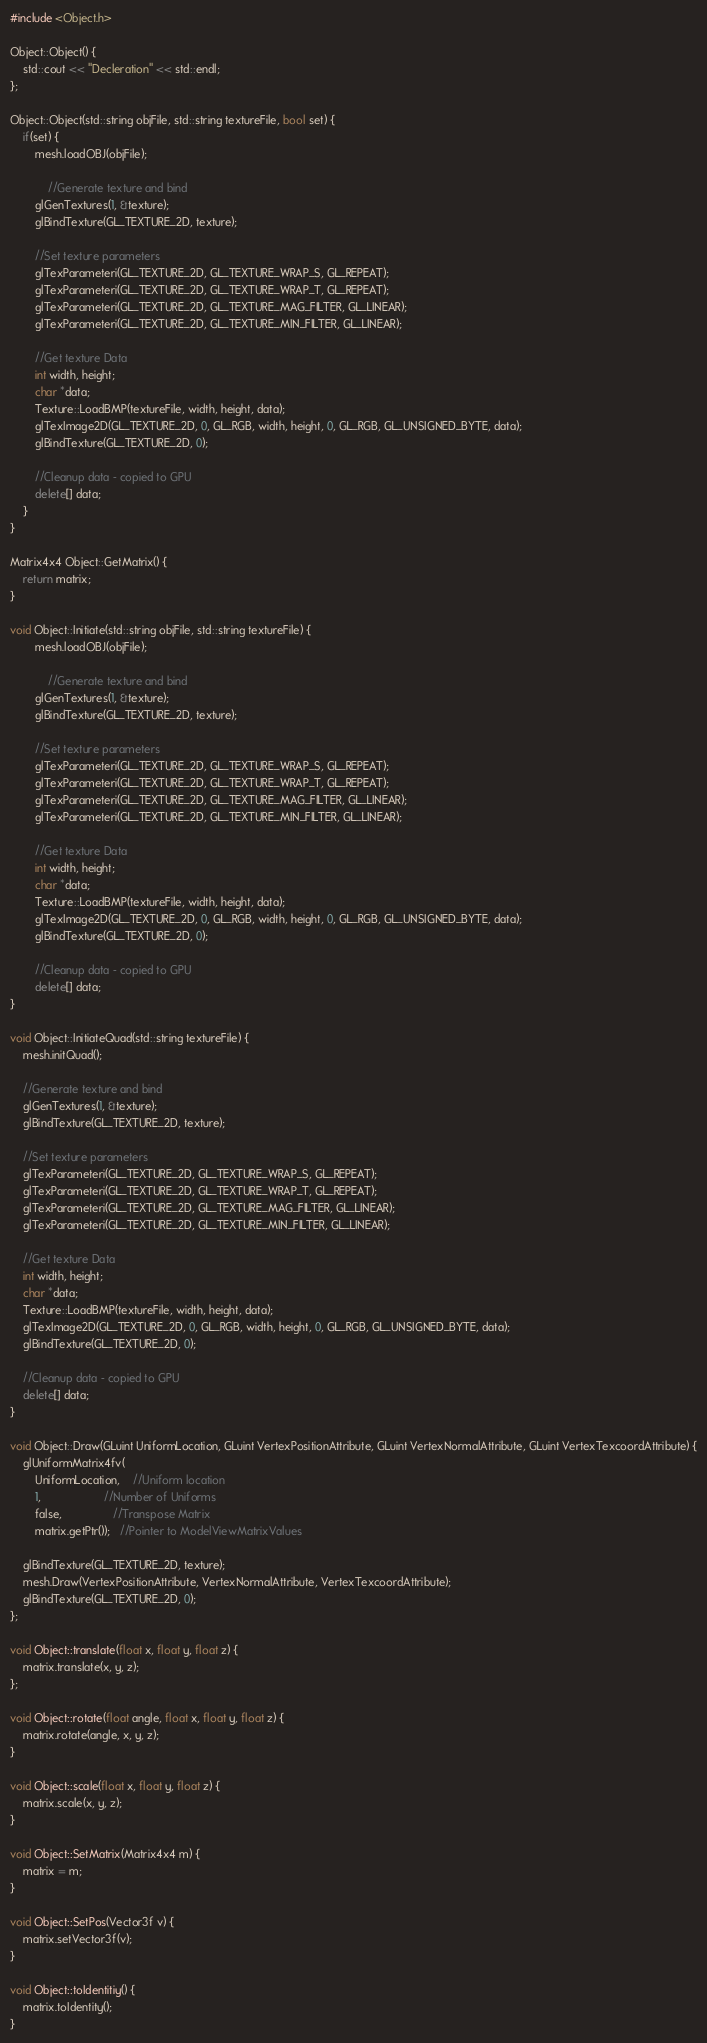Convert code to text. <code><loc_0><loc_0><loc_500><loc_500><_C++_>#include <Object.h>

Object::Object() {
	std::cout << "Decleration" << std::endl;
};

Object::Object(std::string objFile, std::string textureFile, bool set) {
	if(set) {
		mesh.loadOBJ(objFile);

			//Generate texture and bind
		glGenTextures(1, &texture);
		glBindTexture(GL_TEXTURE_2D, texture);

		//Set texture parameters
		glTexParameteri(GL_TEXTURE_2D, GL_TEXTURE_WRAP_S, GL_REPEAT);
		glTexParameteri(GL_TEXTURE_2D, GL_TEXTURE_WRAP_T, GL_REPEAT);
		glTexParameteri(GL_TEXTURE_2D, GL_TEXTURE_MAG_FILTER, GL_LINEAR);
		glTexParameteri(GL_TEXTURE_2D, GL_TEXTURE_MIN_FILTER, GL_LINEAR);

		//Get texture Data
		int width, height;
		char *data;
		Texture::LoadBMP(textureFile, width, height, data);
		glTexImage2D(GL_TEXTURE_2D, 0, GL_RGB, width, height, 0, GL_RGB, GL_UNSIGNED_BYTE, data);
		glBindTexture(GL_TEXTURE_2D, 0);

		//Cleanup data - copied to GPU
		delete[] data;
	}
}

Matrix4x4 Object::GetMatrix() {
    return matrix;
}

void Object::Initiate(std::string objFile, std::string textureFile) {
		mesh.loadOBJ(objFile);

			//Generate texture and bind
		glGenTextures(1, &texture);
		glBindTexture(GL_TEXTURE_2D, texture);

		//Set texture parameters
		glTexParameteri(GL_TEXTURE_2D, GL_TEXTURE_WRAP_S, GL_REPEAT);
		glTexParameteri(GL_TEXTURE_2D, GL_TEXTURE_WRAP_T, GL_REPEAT);
		glTexParameteri(GL_TEXTURE_2D, GL_TEXTURE_MAG_FILTER, GL_LINEAR);
		glTexParameteri(GL_TEXTURE_2D, GL_TEXTURE_MIN_FILTER, GL_LINEAR);

		//Get texture Data
		int width, height;
		char *data;
		Texture::LoadBMP(textureFile, width, height, data);
		glTexImage2D(GL_TEXTURE_2D, 0, GL_RGB, width, height, 0, GL_RGB, GL_UNSIGNED_BYTE, data);
		glBindTexture(GL_TEXTURE_2D, 0);

		//Cleanup data - copied to GPU
		delete[] data;
}

void Object::InitiateQuad(std::string textureFile) {
	mesh.initQuad();

	//Generate texture and bind
	glGenTextures(1, &texture);
	glBindTexture(GL_TEXTURE_2D, texture);

	//Set texture parameters
	glTexParameteri(GL_TEXTURE_2D, GL_TEXTURE_WRAP_S, GL_REPEAT);
	glTexParameteri(GL_TEXTURE_2D, GL_TEXTURE_WRAP_T, GL_REPEAT);
	glTexParameteri(GL_TEXTURE_2D, GL_TEXTURE_MAG_FILTER, GL_LINEAR);
	glTexParameteri(GL_TEXTURE_2D, GL_TEXTURE_MIN_FILTER, GL_LINEAR);

	//Get texture Data
	int width, height;
	char *data;
	Texture::LoadBMP(textureFile, width, height, data);
	glTexImage2D(GL_TEXTURE_2D, 0, GL_RGB, width, height, 0, GL_RGB, GL_UNSIGNED_BYTE, data);
	glBindTexture(GL_TEXTURE_2D, 0);

	//Cleanup data - copied to GPU
	delete[] data;
}

void Object::Draw(GLuint UniformLocation, GLuint VertexPositionAttribute, GLuint VertexNormalAttribute, GLuint VertexTexcoordAttribute) {
    glUniformMatrix4fv(
		UniformLocation,    //Uniform location
		1,					//Number of Uniforms
		false,				//Transpose Matrix
        matrix.getPtr());   //Pointer to ModelViewMatrixValues
    
    glBindTexture(GL_TEXTURE_2D, texture);
    mesh.Draw(VertexPositionAttribute, VertexNormalAttribute, VertexTexcoordAttribute);
    glBindTexture(GL_TEXTURE_2D, 0);
};

void Object::translate(float x, float y, float z) {
	matrix.translate(x, y, z);
};

void Object::rotate(float angle, float x, float y, float z) {
	matrix.rotate(angle, x, y, z);
}

void Object::scale(float x, float y, float z) {
	matrix.scale(x, y, z);
}

void Object::SetMatrix(Matrix4x4 m) {
    matrix = m;
}

void Object::SetPos(Vector3f v) {
	matrix.setVector3f(v);
}

void Object::toIdentitiy() {
    matrix.toIdentity();
}</code> 